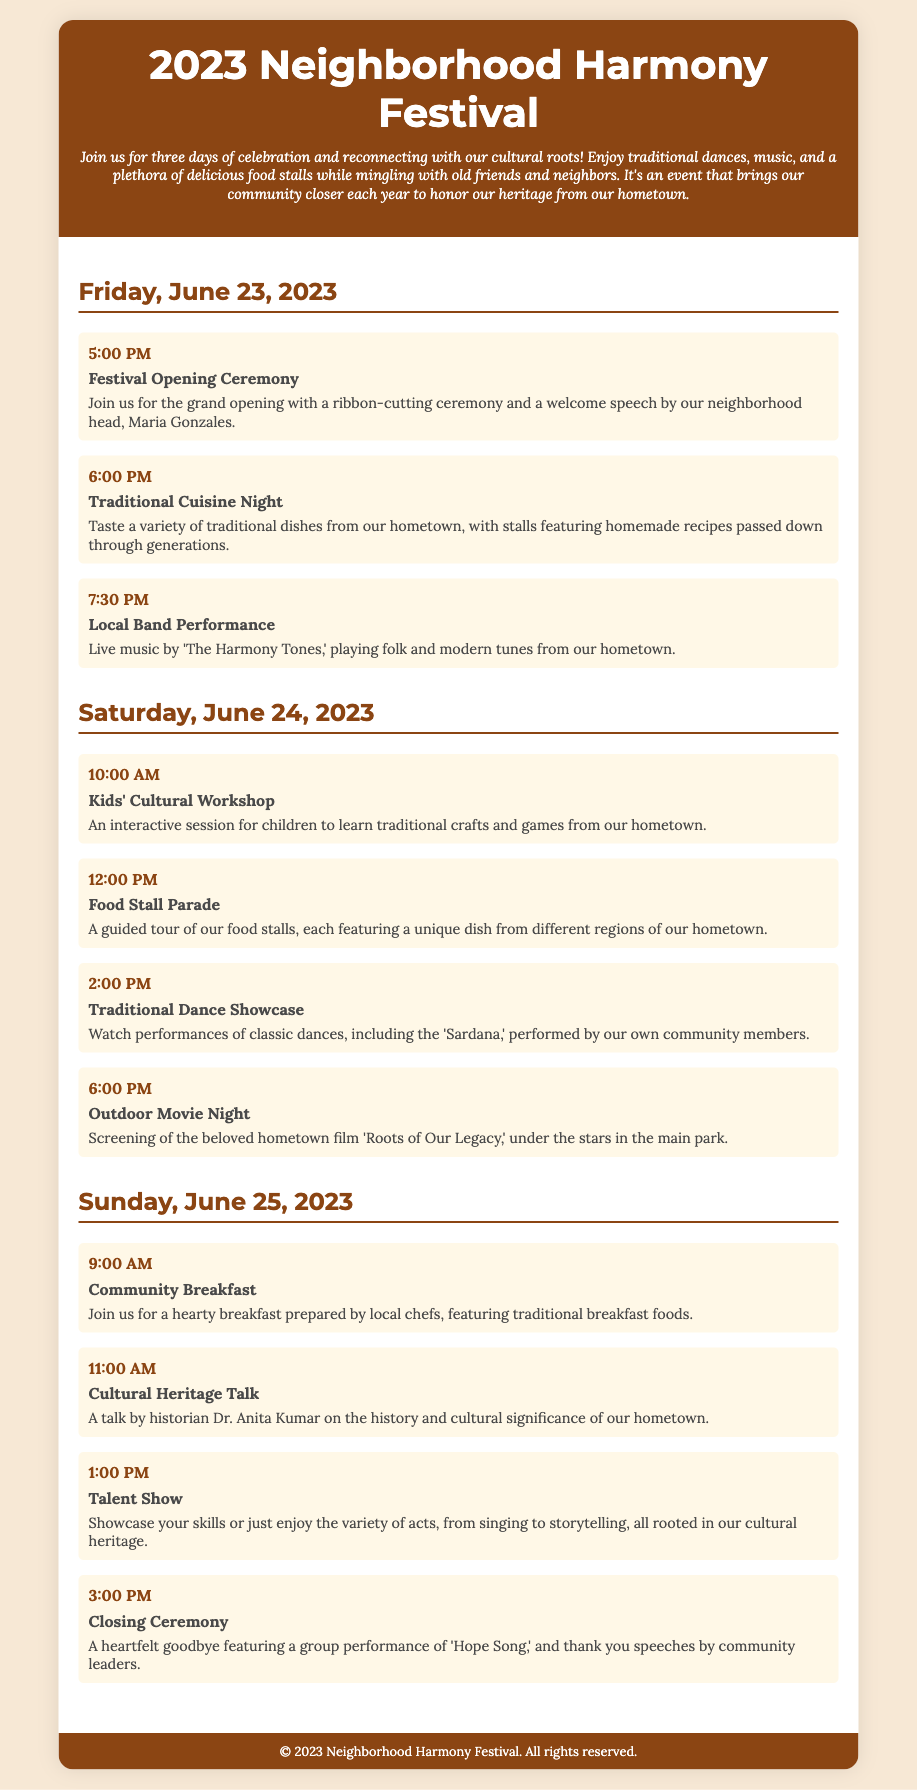What day does the festival start? The festival starts on Friday, June 23, 2023.
Answer: Friday, June 23, 2023 What is the time for the Traditional Dance Showcase? The Traditional Dance Showcase is scheduled for 2:00 PM on Saturday, June 24, 2023.
Answer: 2:00 PM Who is giving the welcome speech at the opening ceremony? Maria Gonzales is giving the welcome speech at the opening ceremony.
Answer: Maria Gonzales What is the title of the film being screened on Saturday night? The film screened on Saturday night is titled 'Roots of Our Legacy.'
Answer: Roots of Our Legacy How many days is the festival taking place? The festival takes place over three days.
Answer: three days What activity is scheduled for Sunday at 11:00 AM? At 11:00 AM on Sunday, there is a Cultural Heritage Talk.
Answer: Cultural Heritage Talk What is the last event of the festival? The last event of the festival is the Closing Ceremony.
Answer: Closing Ceremony What type of performances does 'The Harmony Tones' provide? 'The Harmony Tones' provides folk and modern tunes from our hometown.
Answer: folk and modern tunes When is the Community Breakfast scheduled? The Community Breakfast is scheduled for 9:00 AM on Sunday.
Answer: 9:00 AM 